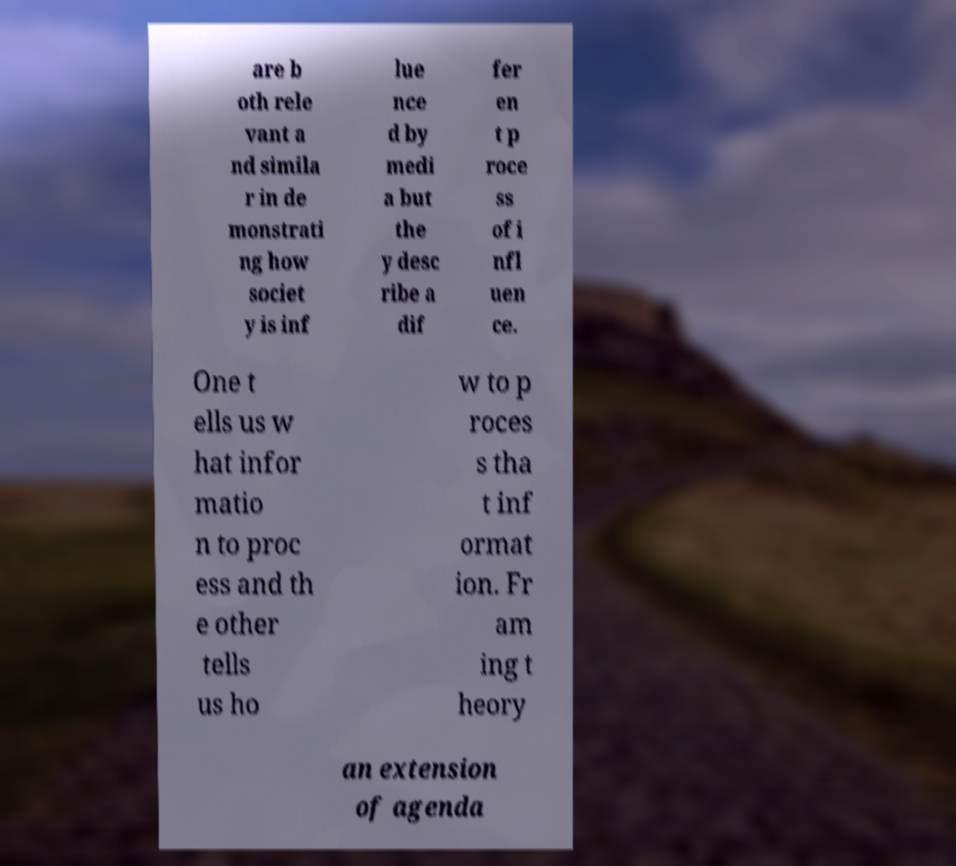Could you assist in decoding the text presented in this image and type it out clearly? are b oth rele vant a nd simila r in de monstrati ng how societ y is inf lue nce d by medi a but the y desc ribe a dif fer en t p roce ss of i nfl uen ce. One t ells us w hat infor matio n to proc ess and th e other tells us ho w to p roces s tha t inf ormat ion. Fr am ing t heory an extension of agenda 